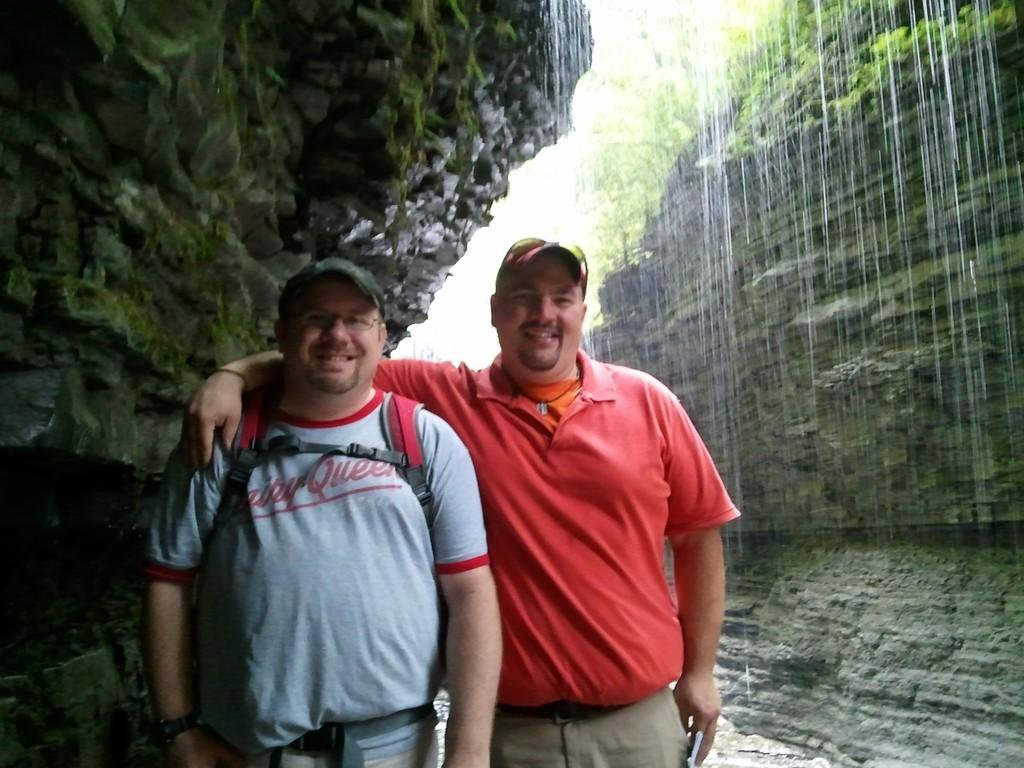<image>
Create a compact narrative representing the image presented. Two men are standing near a waterfall and one man has a Dairy Queen shirt on. 